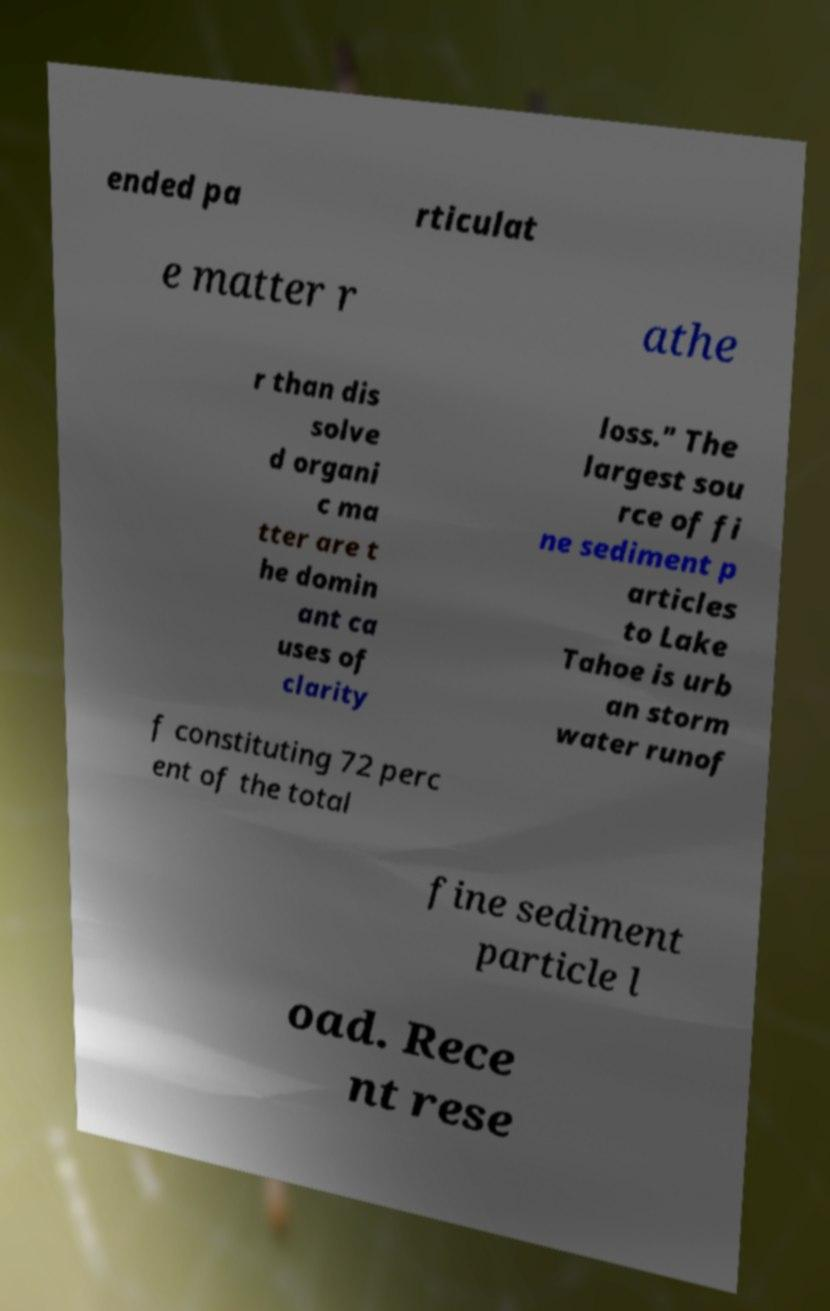Can you read and provide the text displayed in the image?This photo seems to have some interesting text. Can you extract and type it out for me? ended pa rticulat e matter r athe r than dis solve d organi c ma tter are t he domin ant ca uses of clarity loss." The largest sou rce of fi ne sediment p articles to Lake Tahoe is urb an storm water runof f constituting 72 perc ent of the total fine sediment particle l oad. Rece nt rese 